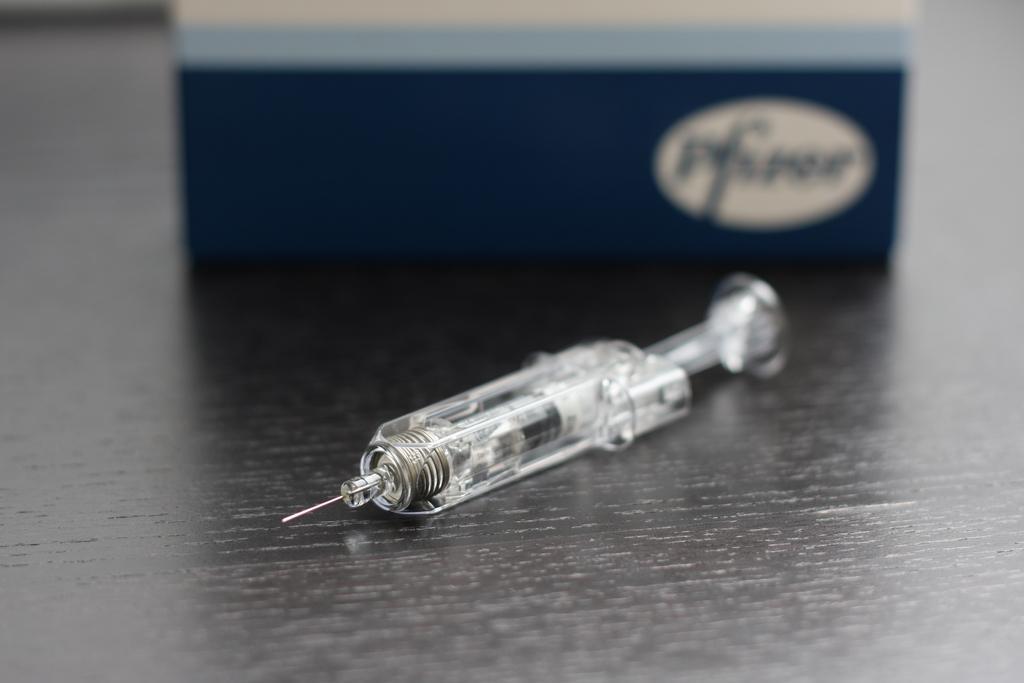In one or two sentences, can you explain what this image depicts? In the picture we can see a wooden plank on it we can see a injection and behind it we can see a blue color box. 